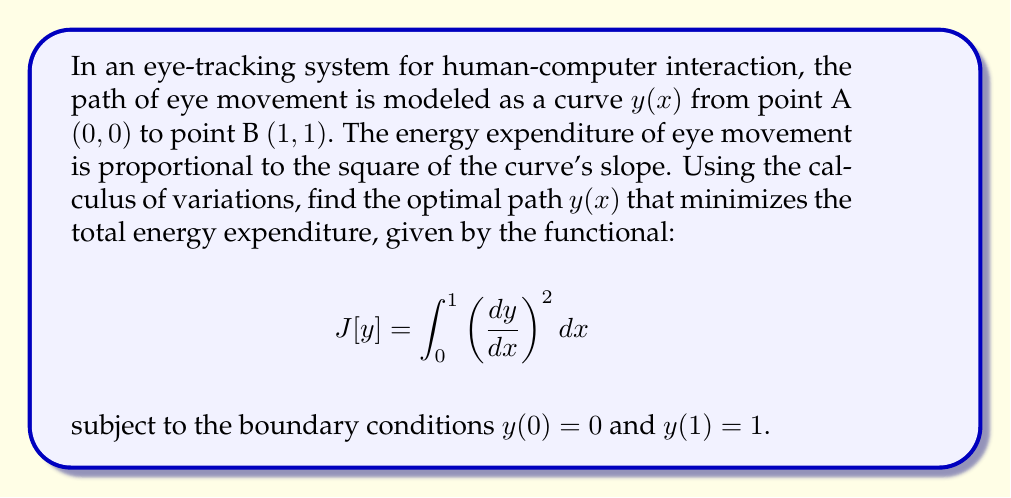Can you solve this math problem? To solve this problem, we'll use the Euler-Lagrange equation from the calculus of variations:

1) The integrand $F(x,y,y') = (y')^2$, where $y' = \frac{dy}{dx}$.

2) The Euler-Lagrange equation is:

   $$\frac{\partial F}{\partial y} - \frac{d}{dx}\left(\frac{\partial F}{\partial y'}\right) = 0$$

3) Calculating the partial derivatives:
   $\frac{\partial F}{\partial y} = 0$
   $\frac{\partial F}{\partial y'} = 2y'$

4) Substituting into the Euler-Lagrange equation:

   $$0 - \frac{d}{dx}(2y') = 0$$

5) Simplifying:
   $$\frac{d}{dx}(2y') = 0$$

6) Integrating both sides:
   $$2y' = C_1$$
   $$y' = \frac{C_1}{2}$$

7) Integrating again:
   $$y = \frac{C_1}{2}x + C_2$$

8) Using the boundary conditions to find $C_1$ and $C_2$:
   $y(0) = 0$: $0 = C_2$
   $y(1) = 1$: $1 = \frac{C_1}{2} + 0$, so $C_1 = 2$

9) The optimal path is therefore:
   $$y(x) = x$$
Answer: $y(x) = x$ 